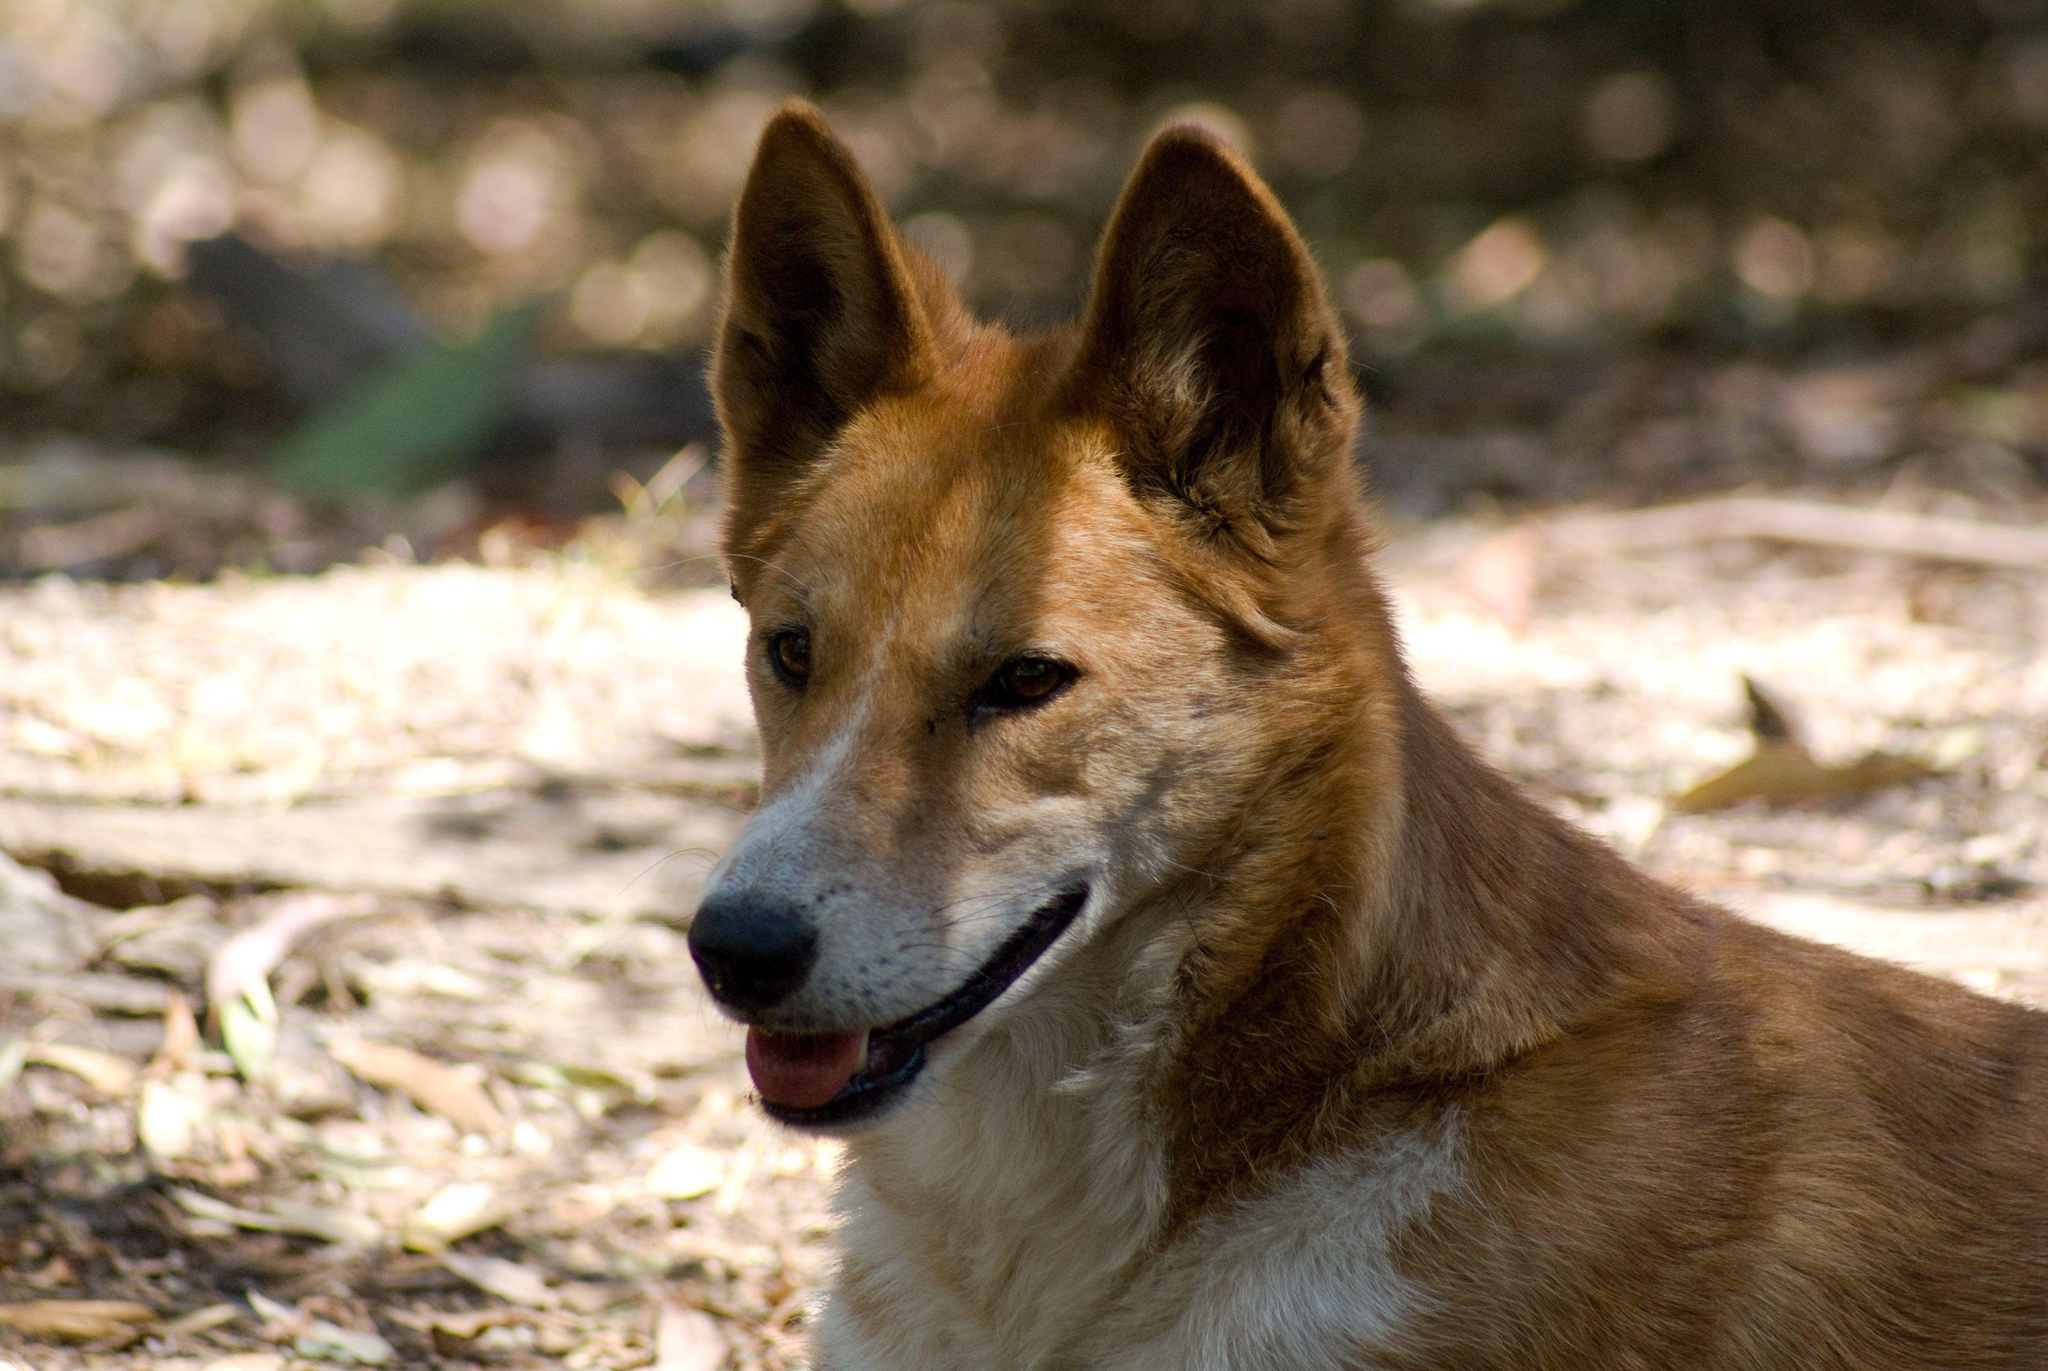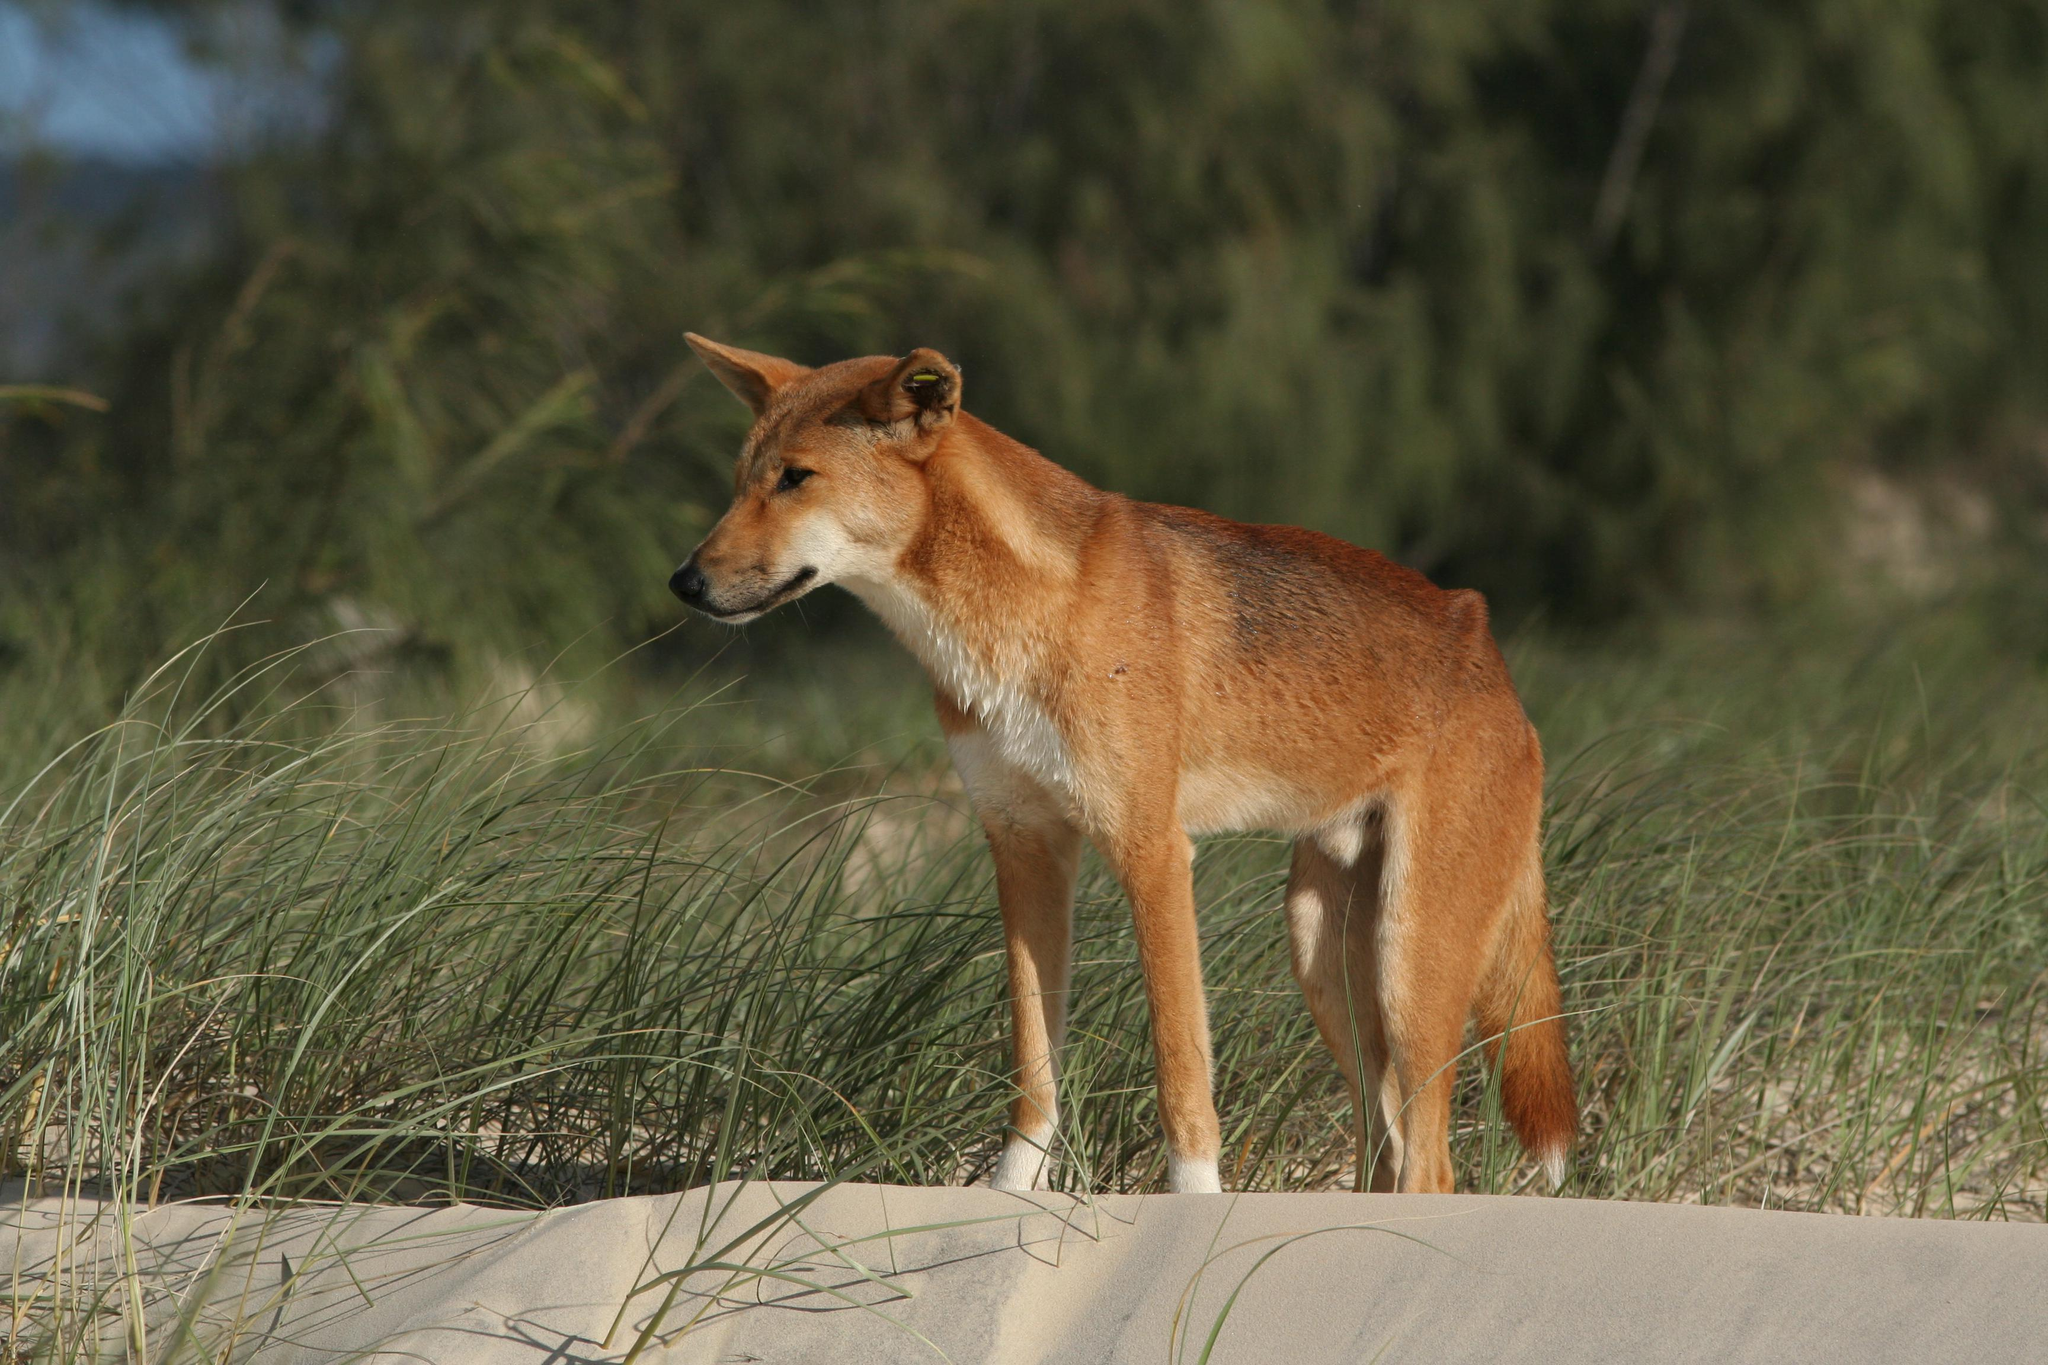The first image is the image on the left, the second image is the image on the right. Assess this claim about the two images: "There is an animal lying down in one of the images". Correct or not? Answer yes or no. No. The first image is the image on the left, the second image is the image on the right. For the images shown, is this caption "A canine is on the ground in a resting pose, in one image." true? Answer yes or no. No. 